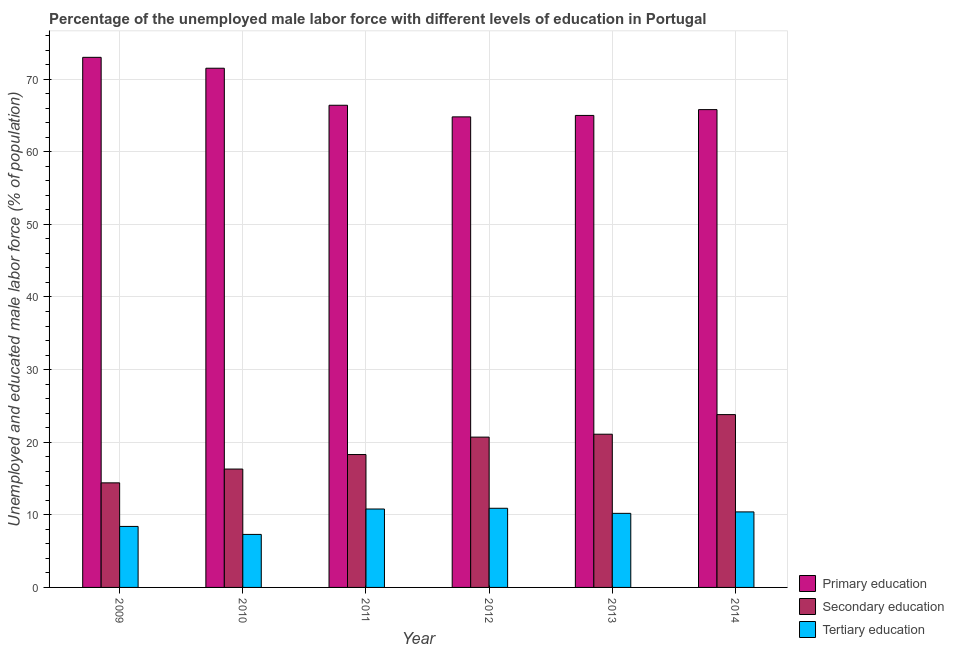How many different coloured bars are there?
Make the answer very short. 3. How many bars are there on the 1st tick from the right?
Your response must be concise. 3. What is the percentage of male labor force who received tertiary education in 2009?
Ensure brevity in your answer.  8.4. Across all years, what is the maximum percentage of male labor force who received tertiary education?
Ensure brevity in your answer.  10.9. Across all years, what is the minimum percentage of male labor force who received primary education?
Ensure brevity in your answer.  64.8. What is the total percentage of male labor force who received secondary education in the graph?
Your answer should be compact. 114.6. What is the difference between the percentage of male labor force who received tertiary education in 2009 and that in 2012?
Your response must be concise. -2.5. What is the difference between the percentage of male labor force who received primary education in 2013 and the percentage of male labor force who received tertiary education in 2011?
Your response must be concise. -1.4. What is the average percentage of male labor force who received secondary education per year?
Your answer should be very brief. 19.1. In the year 2009, what is the difference between the percentage of male labor force who received secondary education and percentage of male labor force who received primary education?
Provide a succinct answer. 0. In how many years, is the percentage of male labor force who received secondary education greater than 38 %?
Your response must be concise. 0. What is the ratio of the percentage of male labor force who received secondary education in 2013 to that in 2014?
Your response must be concise. 0.89. Is the difference between the percentage of male labor force who received tertiary education in 2009 and 2014 greater than the difference between the percentage of male labor force who received secondary education in 2009 and 2014?
Keep it short and to the point. No. What is the difference between the highest and the second highest percentage of male labor force who received secondary education?
Your answer should be compact. 2.7. What is the difference between the highest and the lowest percentage of male labor force who received tertiary education?
Provide a succinct answer. 3.6. In how many years, is the percentage of male labor force who received secondary education greater than the average percentage of male labor force who received secondary education taken over all years?
Offer a terse response. 3. Is the sum of the percentage of male labor force who received primary education in 2012 and 2014 greater than the maximum percentage of male labor force who received secondary education across all years?
Keep it short and to the point. Yes. What does the 2nd bar from the right in 2012 represents?
Offer a very short reply. Secondary education. Are all the bars in the graph horizontal?
Make the answer very short. No. How many years are there in the graph?
Your answer should be compact. 6. What is the difference between two consecutive major ticks on the Y-axis?
Keep it short and to the point. 10. Are the values on the major ticks of Y-axis written in scientific E-notation?
Offer a very short reply. No. Where does the legend appear in the graph?
Give a very brief answer. Bottom right. How many legend labels are there?
Ensure brevity in your answer.  3. What is the title of the graph?
Your response must be concise. Percentage of the unemployed male labor force with different levels of education in Portugal. Does "Natural gas sources" appear as one of the legend labels in the graph?
Offer a terse response. No. What is the label or title of the X-axis?
Your response must be concise. Year. What is the label or title of the Y-axis?
Your answer should be very brief. Unemployed and educated male labor force (% of population). What is the Unemployed and educated male labor force (% of population) of Secondary education in 2009?
Keep it short and to the point. 14.4. What is the Unemployed and educated male labor force (% of population) of Tertiary education in 2009?
Offer a very short reply. 8.4. What is the Unemployed and educated male labor force (% of population) of Primary education in 2010?
Your answer should be compact. 71.5. What is the Unemployed and educated male labor force (% of population) in Secondary education in 2010?
Your answer should be compact. 16.3. What is the Unemployed and educated male labor force (% of population) in Tertiary education in 2010?
Offer a very short reply. 7.3. What is the Unemployed and educated male labor force (% of population) in Primary education in 2011?
Your response must be concise. 66.4. What is the Unemployed and educated male labor force (% of population) of Secondary education in 2011?
Your answer should be very brief. 18.3. What is the Unemployed and educated male labor force (% of population) of Tertiary education in 2011?
Provide a succinct answer. 10.8. What is the Unemployed and educated male labor force (% of population) in Primary education in 2012?
Offer a terse response. 64.8. What is the Unemployed and educated male labor force (% of population) in Secondary education in 2012?
Ensure brevity in your answer.  20.7. What is the Unemployed and educated male labor force (% of population) in Tertiary education in 2012?
Provide a short and direct response. 10.9. What is the Unemployed and educated male labor force (% of population) in Secondary education in 2013?
Provide a short and direct response. 21.1. What is the Unemployed and educated male labor force (% of population) in Tertiary education in 2013?
Make the answer very short. 10.2. What is the Unemployed and educated male labor force (% of population) in Primary education in 2014?
Keep it short and to the point. 65.8. What is the Unemployed and educated male labor force (% of population) in Secondary education in 2014?
Give a very brief answer. 23.8. What is the Unemployed and educated male labor force (% of population) in Tertiary education in 2014?
Your answer should be very brief. 10.4. Across all years, what is the maximum Unemployed and educated male labor force (% of population) of Primary education?
Offer a terse response. 73. Across all years, what is the maximum Unemployed and educated male labor force (% of population) of Secondary education?
Keep it short and to the point. 23.8. Across all years, what is the maximum Unemployed and educated male labor force (% of population) of Tertiary education?
Your answer should be very brief. 10.9. Across all years, what is the minimum Unemployed and educated male labor force (% of population) of Primary education?
Provide a succinct answer. 64.8. Across all years, what is the minimum Unemployed and educated male labor force (% of population) in Secondary education?
Ensure brevity in your answer.  14.4. Across all years, what is the minimum Unemployed and educated male labor force (% of population) in Tertiary education?
Keep it short and to the point. 7.3. What is the total Unemployed and educated male labor force (% of population) in Primary education in the graph?
Provide a short and direct response. 406.5. What is the total Unemployed and educated male labor force (% of population) in Secondary education in the graph?
Provide a succinct answer. 114.6. What is the difference between the Unemployed and educated male labor force (% of population) of Secondary education in 2009 and that in 2010?
Offer a terse response. -1.9. What is the difference between the Unemployed and educated male labor force (% of population) of Tertiary education in 2009 and that in 2010?
Your answer should be very brief. 1.1. What is the difference between the Unemployed and educated male labor force (% of population) of Primary education in 2009 and that in 2011?
Offer a terse response. 6.6. What is the difference between the Unemployed and educated male labor force (% of population) in Secondary education in 2009 and that in 2011?
Your response must be concise. -3.9. What is the difference between the Unemployed and educated male labor force (% of population) in Tertiary education in 2009 and that in 2012?
Offer a very short reply. -2.5. What is the difference between the Unemployed and educated male labor force (% of population) of Primary education in 2009 and that in 2013?
Your answer should be very brief. 8. What is the difference between the Unemployed and educated male labor force (% of population) in Primary education in 2009 and that in 2014?
Provide a succinct answer. 7.2. What is the difference between the Unemployed and educated male labor force (% of population) of Tertiary education in 2010 and that in 2012?
Keep it short and to the point. -3.6. What is the difference between the Unemployed and educated male labor force (% of population) in Secondary education in 2010 and that in 2013?
Provide a succinct answer. -4.8. What is the difference between the Unemployed and educated male labor force (% of population) of Tertiary education in 2010 and that in 2013?
Give a very brief answer. -2.9. What is the difference between the Unemployed and educated male labor force (% of population) of Primary education in 2010 and that in 2014?
Give a very brief answer. 5.7. What is the difference between the Unemployed and educated male labor force (% of population) of Secondary education in 2010 and that in 2014?
Make the answer very short. -7.5. What is the difference between the Unemployed and educated male labor force (% of population) in Primary education in 2011 and that in 2013?
Your answer should be very brief. 1.4. What is the difference between the Unemployed and educated male labor force (% of population) of Secondary education in 2011 and that in 2013?
Provide a short and direct response. -2.8. What is the difference between the Unemployed and educated male labor force (% of population) of Tertiary education in 2011 and that in 2013?
Your response must be concise. 0.6. What is the difference between the Unemployed and educated male labor force (% of population) of Primary education in 2012 and that in 2013?
Make the answer very short. -0.2. What is the difference between the Unemployed and educated male labor force (% of population) of Primary education in 2012 and that in 2014?
Your answer should be very brief. -1. What is the difference between the Unemployed and educated male labor force (% of population) of Secondary education in 2012 and that in 2014?
Make the answer very short. -3.1. What is the difference between the Unemployed and educated male labor force (% of population) in Tertiary education in 2012 and that in 2014?
Your response must be concise. 0.5. What is the difference between the Unemployed and educated male labor force (% of population) of Tertiary education in 2013 and that in 2014?
Offer a terse response. -0.2. What is the difference between the Unemployed and educated male labor force (% of population) of Primary education in 2009 and the Unemployed and educated male labor force (% of population) of Secondary education in 2010?
Keep it short and to the point. 56.7. What is the difference between the Unemployed and educated male labor force (% of population) in Primary education in 2009 and the Unemployed and educated male labor force (% of population) in Tertiary education in 2010?
Your response must be concise. 65.7. What is the difference between the Unemployed and educated male labor force (% of population) of Secondary education in 2009 and the Unemployed and educated male labor force (% of population) of Tertiary education in 2010?
Make the answer very short. 7.1. What is the difference between the Unemployed and educated male labor force (% of population) in Primary education in 2009 and the Unemployed and educated male labor force (% of population) in Secondary education in 2011?
Give a very brief answer. 54.7. What is the difference between the Unemployed and educated male labor force (% of population) of Primary education in 2009 and the Unemployed and educated male labor force (% of population) of Tertiary education in 2011?
Provide a short and direct response. 62.2. What is the difference between the Unemployed and educated male labor force (% of population) in Primary education in 2009 and the Unemployed and educated male labor force (% of population) in Secondary education in 2012?
Provide a succinct answer. 52.3. What is the difference between the Unemployed and educated male labor force (% of population) of Primary education in 2009 and the Unemployed and educated male labor force (% of population) of Tertiary education in 2012?
Provide a succinct answer. 62.1. What is the difference between the Unemployed and educated male labor force (% of population) in Secondary education in 2009 and the Unemployed and educated male labor force (% of population) in Tertiary education in 2012?
Provide a short and direct response. 3.5. What is the difference between the Unemployed and educated male labor force (% of population) in Primary education in 2009 and the Unemployed and educated male labor force (% of population) in Secondary education in 2013?
Give a very brief answer. 51.9. What is the difference between the Unemployed and educated male labor force (% of population) in Primary education in 2009 and the Unemployed and educated male labor force (% of population) in Tertiary education in 2013?
Make the answer very short. 62.8. What is the difference between the Unemployed and educated male labor force (% of population) of Primary education in 2009 and the Unemployed and educated male labor force (% of population) of Secondary education in 2014?
Your answer should be very brief. 49.2. What is the difference between the Unemployed and educated male labor force (% of population) in Primary education in 2009 and the Unemployed and educated male labor force (% of population) in Tertiary education in 2014?
Ensure brevity in your answer.  62.6. What is the difference between the Unemployed and educated male labor force (% of population) of Primary education in 2010 and the Unemployed and educated male labor force (% of population) of Secondary education in 2011?
Your answer should be very brief. 53.2. What is the difference between the Unemployed and educated male labor force (% of population) of Primary education in 2010 and the Unemployed and educated male labor force (% of population) of Tertiary education in 2011?
Your response must be concise. 60.7. What is the difference between the Unemployed and educated male labor force (% of population) of Secondary education in 2010 and the Unemployed and educated male labor force (% of population) of Tertiary education in 2011?
Give a very brief answer. 5.5. What is the difference between the Unemployed and educated male labor force (% of population) of Primary education in 2010 and the Unemployed and educated male labor force (% of population) of Secondary education in 2012?
Your answer should be compact. 50.8. What is the difference between the Unemployed and educated male labor force (% of population) in Primary education in 2010 and the Unemployed and educated male labor force (% of population) in Tertiary education in 2012?
Offer a terse response. 60.6. What is the difference between the Unemployed and educated male labor force (% of population) in Secondary education in 2010 and the Unemployed and educated male labor force (% of population) in Tertiary education in 2012?
Make the answer very short. 5.4. What is the difference between the Unemployed and educated male labor force (% of population) of Primary education in 2010 and the Unemployed and educated male labor force (% of population) of Secondary education in 2013?
Offer a terse response. 50.4. What is the difference between the Unemployed and educated male labor force (% of population) of Primary education in 2010 and the Unemployed and educated male labor force (% of population) of Tertiary education in 2013?
Make the answer very short. 61.3. What is the difference between the Unemployed and educated male labor force (% of population) of Primary education in 2010 and the Unemployed and educated male labor force (% of population) of Secondary education in 2014?
Keep it short and to the point. 47.7. What is the difference between the Unemployed and educated male labor force (% of population) of Primary education in 2010 and the Unemployed and educated male labor force (% of population) of Tertiary education in 2014?
Offer a terse response. 61.1. What is the difference between the Unemployed and educated male labor force (% of population) in Primary education in 2011 and the Unemployed and educated male labor force (% of population) in Secondary education in 2012?
Give a very brief answer. 45.7. What is the difference between the Unemployed and educated male labor force (% of population) in Primary education in 2011 and the Unemployed and educated male labor force (% of population) in Tertiary education in 2012?
Your answer should be compact. 55.5. What is the difference between the Unemployed and educated male labor force (% of population) in Primary education in 2011 and the Unemployed and educated male labor force (% of population) in Secondary education in 2013?
Your answer should be very brief. 45.3. What is the difference between the Unemployed and educated male labor force (% of population) of Primary education in 2011 and the Unemployed and educated male labor force (% of population) of Tertiary education in 2013?
Provide a short and direct response. 56.2. What is the difference between the Unemployed and educated male labor force (% of population) in Primary education in 2011 and the Unemployed and educated male labor force (% of population) in Secondary education in 2014?
Provide a succinct answer. 42.6. What is the difference between the Unemployed and educated male labor force (% of population) of Primary education in 2011 and the Unemployed and educated male labor force (% of population) of Tertiary education in 2014?
Your answer should be compact. 56. What is the difference between the Unemployed and educated male labor force (% of population) in Secondary education in 2011 and the Unemployed and educated male labor force (% of population) in Tertiary education in 2014?
Offer a terse response. 7.9. What is the difference between the Unemployed and educated male labor force (% of population) in Primary education in 2012 and the Unemployed and educated male labor force (% of population) in Secondary education in 2013?
Ensure brevity in your answer.  43.7. What is the difference between the Unemployed and educated male labor force (% of population) of Primary education in 2012 and the Unemployed and educated male labor force (% of population) of Tertiary education in 2013?
Your response must be concise. 54.6. What is the difference between the Unemployed and educated male labor force (% of population) of Secondary education in 2012 and the Unemployed and educated male labor force (% of population) of Tertiary education in 2013?
Your answer should be compact. 10.5. What is the difference between the Unemployed and educated male labor force (% of population) in Primary education in 2012 and the Unemployed and educated male labor force (% of population) in Tertiary education in 2014?
Provide a short and direct response. 54.4. What is the difference between the Unemployed and educated male labor force (% of population) in Secondary education in 2012 and the Unemployed and educated male labor force (% of population) in Tertiary education in 2014?
Keep it short and to the point. 10.3. What is the difference between the Unemployed and educated male labor force (% of population) in Primary education in 2013 and the Unemployed and educated male labor force (% of population) in Secondary education in 2014?
Provide a succinct answer. 41.2. What is the difference between the Unemployed and educated male labor force (% of population) in Primary education in 2013 and the Unemployed and educated male labor force (% of population) in Tertiary education in 2014?
Offer a terse response. 54.6. What is the average Unemployed and educated male labor force (% of population) of Primary education per year?
Make the answer very short. 67.75. What is the average Unemployed and educated male labor force (% of population) in Secondary education per year?
Your answer should be very brief. 19.1. What is the average Unemployed and educated male labor force (% of population) in Tertiary education per year?
Keep it short and to the point. 9.67. In the year 2009, what is the difference between the Unemployed and educated male labor force (% of population) in Primary education and Unemployed and educated male labor force (% of population) in Secondary education?
Offer a very short reply. 58.6. In the year 2009, what is the difference between the Unemployed and educated male labor force (% of population) of Primary education and Unemployed and educated male labor force (% of population) of Tertiary education?
Keep it short and to the point. 64.6. In the year 2010, what is the difference between the Unemployed and educated male labor force (% of population) in Primary education and Unemployed and educated male labor force (% of population) in Secondary education?
Your answer should be compact. 55.2. In the year 2010, what is the difference between the Unemployed and educated male labor force (% of population) in Primary education and Unemployed and educated male labor force (% of population) in Tertiary education?
Offer a very short reply. 64.2. In the year 2010, what is the difference between the Unemployed and educated male labor force (% of population) of Secondary education and Unemployed and educated male labor force (% of population) of Tertiary education?
Ensure brevity in your answer.  9. In the year 2011, what is the difference between the Unemployed and educated male labor force (% of population) of Primary education and Unemployed and educated male labor force (% of population) of Secondary education?
Provide a short and direct response. 48.1. In the year 2011, what is the difference between the Unemployed and educated male labor force (% of population) of Primary education and Unemployed and educated male labor force (% of population) of Tertiary education?
Ensure brevity in your answer.  55.6. In the year 2012, what is the difference between the Unemployed and educated male labor force (% of population) of Primary education and Unemployed and educated male labor force (% of population) of Secondary education?
Your response must be concise. 44.1. In the year 2012, what is the difference between the Unemployed and educated male labor force (% of population) of Primary education and Unemployed and educated male labor force (% of population) of Tertiary education?
Provide a short and direct response. 53.9. In the year 2012, what is the difference between the Unemployed and educated male labor force (% of population) of Secondary education and Unemployed and educated male labor force (% of population) of Tertiary education?
Your answer should be compact. 9.8. In the year 2013, what is the difference between the Unemployed and educated male labor force (% of population) of Primary education and Unemployed and educated male labor force (% of population) of Secondary education?
Keep it short and to the point. 43.9. In the year 2013, what is the difference between the Unemployed and educated male labor force (% of population) in Primary education and Unemployed and educated male labor force (% of population) in Tertiary education?
Your response must be concise. 54.8. In the year 2013, what is the difference between the Unemployed and educated male labor force (% of population) of Secondary education and Unemployed and educated male labor force (% of population) of Tertiary education?
Ensure brevity in your answer.  10.9. In the year 2014, what is the difference between the Unemployed and educated male labor force (% of population) of Primary education and Unemployed and educated male labor force (% of population) of Tertiary education?
Give a very brief answer. 55.4. In the year 2014, what is the difference between the Unemployed and educated male labor force (% of population) of Secondary education and Unemployed and educated male labor force (% of population) of Tertiary education?
Your answer should be compact. 13.4. What is the ratio of the Unemployed and educated male labor force (% of population) of Primary education in 2009 to that in 2010?
Your answer should be very brief. 1.02. What is the ratio of the Unemployed and educated male labor force (% of population) in Secondary education in 2009 to that in 2010?
Provide a succinct answer. 0.88. What is the ratio of the Unemployed and educated male labor force (% of population) of Tertiary education in 2009 to that in 2010?
Your answer should be very brief. 1.15. What is the ratio of the Unemployed and educated male labor force (% of population) in Primary education in 2009 to that in 2011?
Keep it short and to the point. 1.1. What is the ratio of the Unemployed and educated male labor force (% of population) of Secondary education in 2009 to that in 2011?
Offer a terse response. 0.79. What is the ratio of the Unemployed and educated male labor force (% of population) of Primary education in 2009 to that in 2012?
Provide a succinct answer. 1.13. What is the ratio of the Unemployed and educated male labor force (% of population) of Secondary education in 2009 to that in 2012?
Make the answer very short. 0.7. What is the ratio of the Unemployed and educated male labor force (% of population) in Tertiary education in 2009 to that in 2012?
Offer a very short reply. 0.77. What is the ratio of the Unemployed and educated male labor force (% of population) in Primary education in 2009 to that in 2013?
Provide a short and direct response. 1.12. What is the ratio of the Unemployed and educated male labor force (% of population) of Secondary education in 2009 to that in 2013?
Offer a very short reply. 0.68. What is the ratio of the Unemployed and educated male labor force (% of population) of Tertiary education in 2009 to that in 2013?
Ensure brevity in your answer.  0.82. What is the ratio of the Unemployed and educated male labor force (% of population) in Primary education in 2009 to that in 2014?
Your response must be concise. 1.11. What is the ratio of the Unemployed and educated male labor force (% of population) of Secondary education in 2009 to that in 2014?
Your answer should be compact. 0.6. What is the ratio of the Unemployed and educated male labor force (% of population) of Tertiary education in 2009 to that in 2014?
Provide a succinct answer. 0.81. What is the ratio of the Unemployed and educated male labor force (% of population) of Primary education in 2010 to that in 2011?
Your response must be concise. 1.08. What is the ratio of the Unemployed and educated male labor force (% of population) in Secondary education in 2010 to that in 2011?
Your answer should be compact. 0.89. What is the ratio of the Unemployed and educated male labor force (% of population) in Tertiary education in 2010 to that in 2011?
Offer a terse response. 0.68. What is the ratio of the Unemployed and educated male labor force (% of population) in Primary education in 2010 to that in 2012?
Offer a terse response. 1.1. What is the ratio of the Unemployed and educated male labor force (% of population) in Secondary education in 2010 to that in 2012?
Keep it short and to the point. 0.79. What is the ratio of the Unemployed and educated male labor force (% of population) of Tertiary education in 2010 to that in 2012?
Your answer should be compact. 0.67. What is the ratio of the Unemployed and educated male labor force (% of population) of Secondary education in 2010 to that in 2013?
Your answer should be compact. 0.77. What is the ratio of the Unemployed and educated male labor force (% of population) in Tertiary education in 2010 to that in 2013?
Give a very brief answer. 0.72. What is the ratio of the Unemployed and educated male labor force (% of population) of Primary education in 2010 to that in 2014?
Offer a very short reply. 1.09. What is the ratio of the Unemployed and educated male labor force (% of population) in Secondary education in 2010 to that in 2014?
Give a very brief answer. 0.68. What is the ratio of the Unemployed and educated male labor force (% of population) in Tertiary education in 2010 to that in 2014?
Your response must be concise. 0.7. What is the ratio of the Unemployed and educated male labor force (% of population) of Primary education in 2011 to that in 2012?
Your answer should be compact. 1.02. What is the ratio of the Unemployed and educated male labor force (% of population) in Secondary education in 2011 to that in 2012?
Provide a succinct answer. 0.88. What is the ratio of the Unemployed and educated male labor force (% of population) in Primary education in 2011 to that in 2013?
Provide a succinct answer. 1.02. What is the ratio of the Unemployed and educated male labor force (% of population) in Secondary education in 2011 to that in 2013?
Ensure brevity in your answer.  0.87. What is the ratio of the Unemployed and educated male labor force (% of population) of Tertiary education in 2011 to that in 2013?
Your answer should be very brief. 1.06. What is the ratio of the Unemployed and educated male labor force (% of population) of Primary education in 2011 to that in 2014?
Your response must be concise. 1.01. What is the ratio of the Unemployed and educated male labor force (% of population) in Secondary education in 2011 to that in 2014?
Your response must be concise. 0.77. What is the ratio of the Unemployed and educated male labor force (% of population) of Tertiary education in 2011 to that in 2014?
Your response must be concise. 1.04. What is the ratio of the Unemployed and educated male labor force (% of population) of Tertiary education in 2012 to that in 2013?
Offer a terse response. 1.07. What is the ratio of the Unemployed and educated male labor force (% of population) of Primary education in 2012 to that in 2014?
Keep it short and to the point. 0.98. What is the ratio of the Unemployed and educated male labor force (% of population) of Secondary education in 2012 to that in 2014?
Your answer should be compact. 0.87. What is the ratio of the Unemployed and educated male labor force (% of population) of Tertiary education in 2012 to that in 2014?
Offer a terse response. 1.05. What is the ratio of the Unemployed and educated male labor force (% of population) of Primary education in 2013 to that in 2014?
Your answer should be compact. 0.99. What is the ratio of the Unemployed and educated male labor force (% of population) in Secondary education in 2013 to that in 2014?
Your answer should be very brief. 0.89. What is the ratio of the Unemployed and educated male labor force (% of population) of Tertiary education in 2013 to that in 2014?
Provide a short and direct response. 0.98. What is the difference between the highest and the second highest Unemployed and educated male labor force (% of population) of Primary education?
Your answer should be very brief. 1.5. What is the difference between the highest and the second highest Unemployed and educated male labor force (% of population) in Secondary education?
Ensure brevity in your answer.  2.7. What is the difference between the highest and the lowest Unemployed and educated male labor force (% of population) of Primary education?
Give a very brief answer. 8.2. 